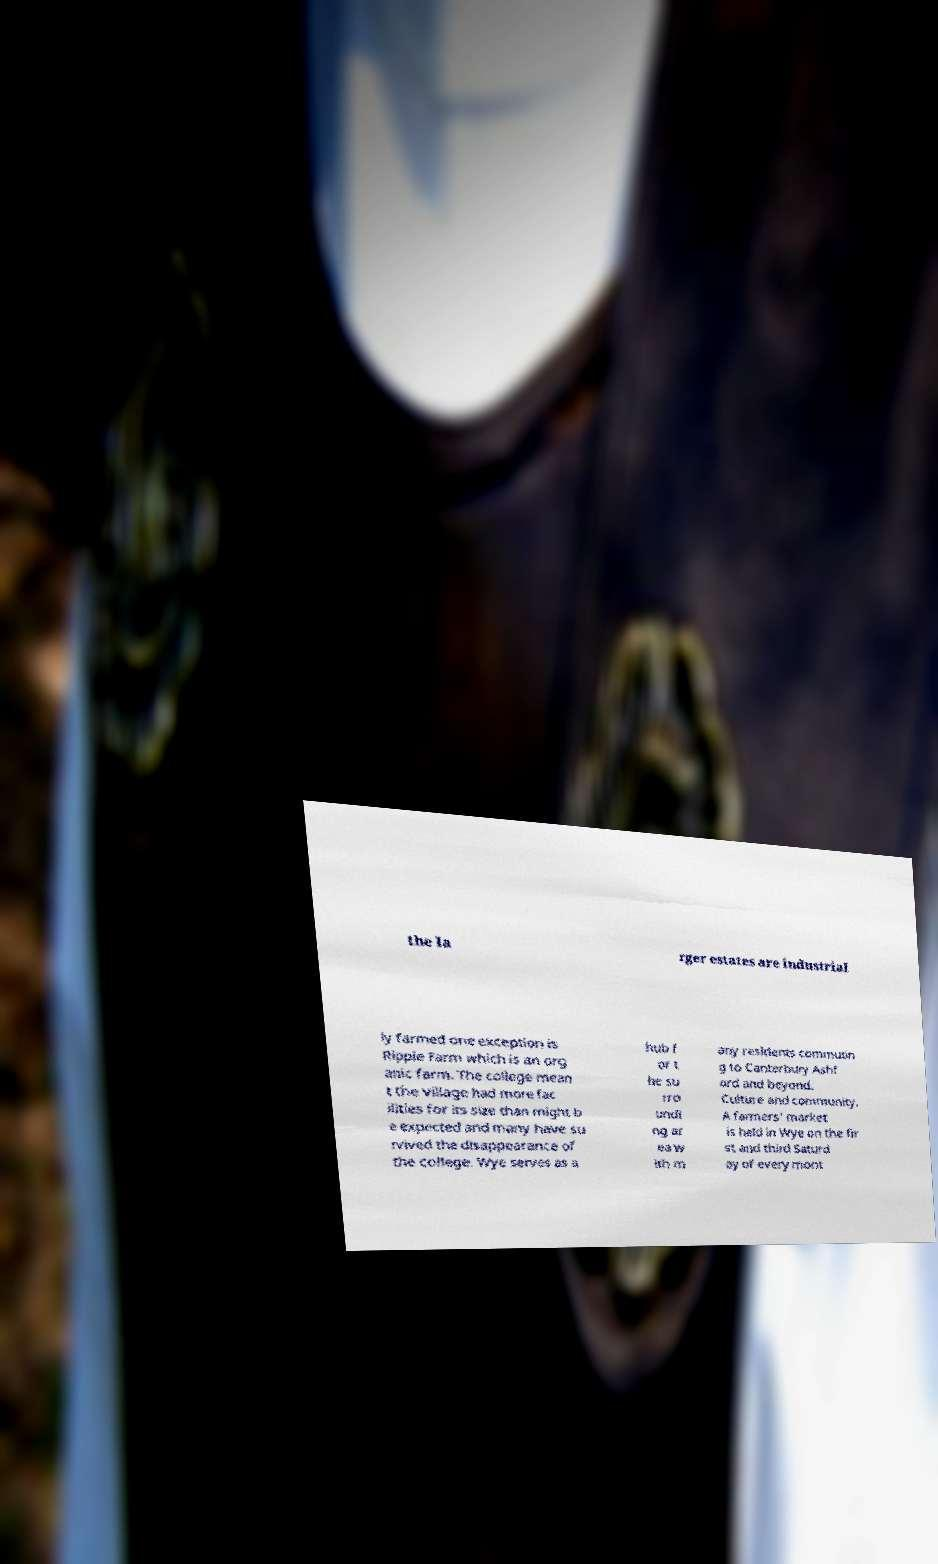There's text embedded in this image that I need extracted. Can you transcribe it verbatim? the la rger estates are industrial ly farmed one exception is Ripple Farm which is an org anic farm. The college mean t the village had more fac ilities for its size than might b e expected and many have su rvived the disappearance of the college. Wye serves as a hub f or t he su rro undi ng ar ea w ith m any residents commutin g to Canterbury Ashf ord and beyond. Culture and community. A farmers' market is held in Wye on the fir st and third Saturd ay of every mont 